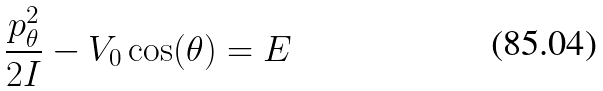Convert formula to latex. <formula><loc_0><loc_0><loc_500><loc_500>\frac { p _ { \theta } ^ { 2 } } { 2 I } - V _ { 0 } \cos ( \theta ) = E</formula> 